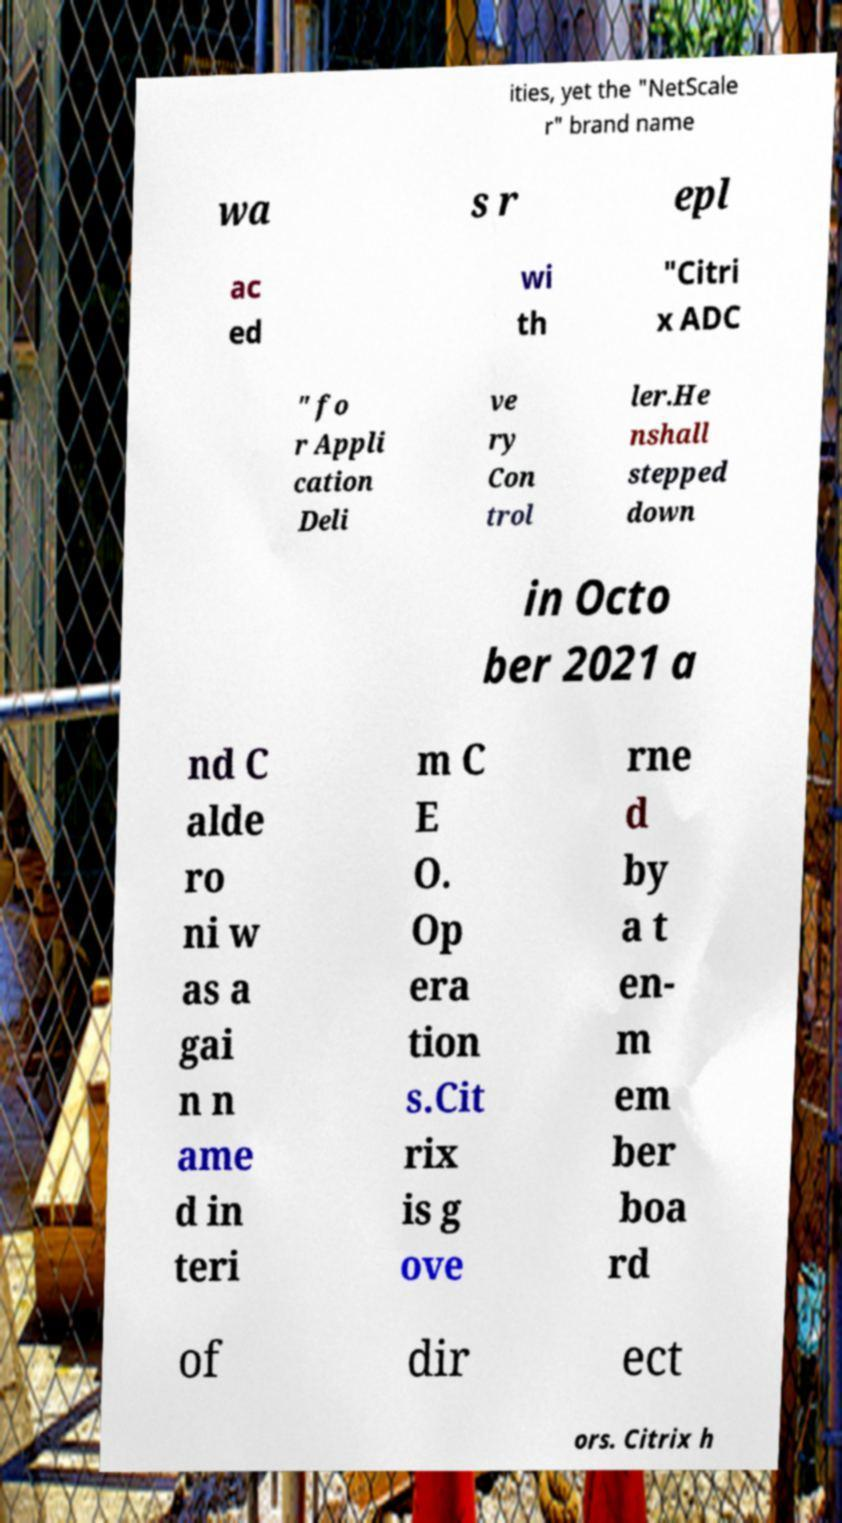I need the written content from this picture converted into text. Can you do that? ities, yet the "NetScale r" brand name wa s r epl ac ed wi th "Citri x ADC " fo r Appli cation Deli ve ry Con trol ler.He nshall stepped down in Octo ber 2021 a nd C alde ro ni w as a gai n n ame d in teri m C E O. Op era tion s.Cit rix is g ove rne d by a t en- m em ber boa rd of dir ect ors. Citrix h 